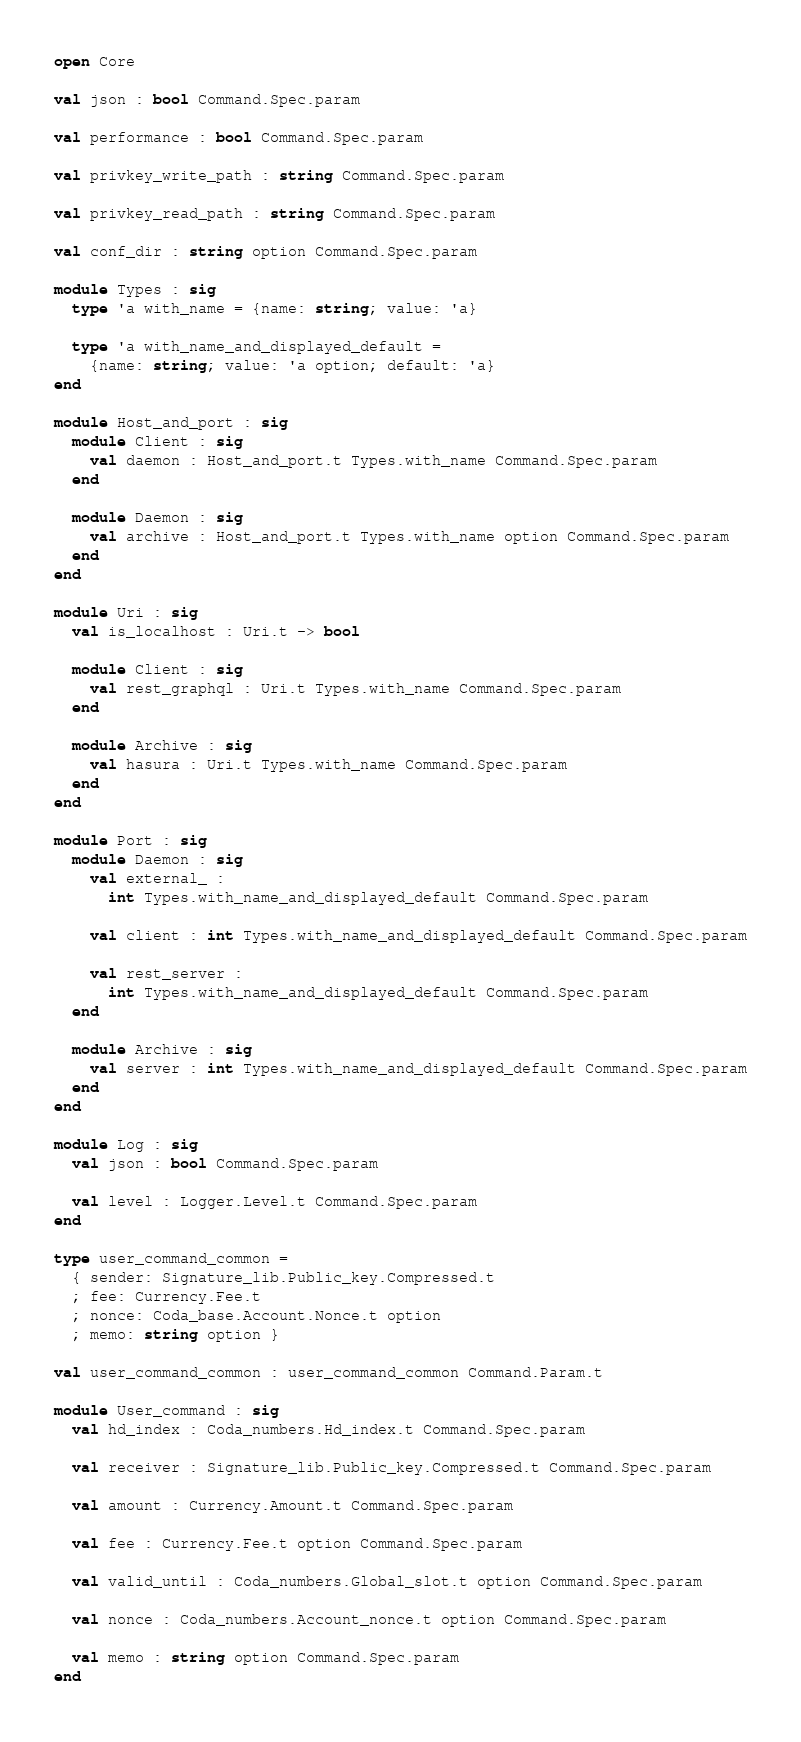Convert code to text. <code><loc_0><loc_0><loc_500><loc_500><_OCaml_>open Core

val json : bool Command.Spec.param

val performance : bool Command.Spec.param

val privkey_write_path : string Command.Spec.param

val privkey_read_path : string Command.Spec.param

val conf_dir : string option Command.Spec.param

module Types : sig
  type 'a with_name = {name: string; value: 'a}

  type 'a with_name_and_displayed_default =
    {name: string; value: 'a option; default: 'a}
end

module Host_and_port : sig
  module Client : sig
    val daemon : Host_and_port.t Types.with_name Command.Spec.param
  end

  module Daemon : sig
    val archive : Host_and_port.t Types.with_name option Command.Spec.param
  end
end

module Uri : sig
  val is_localhost : Uri.t -> bool

  module Client : sig
    val rest_graphql : Uri.t Types.with_name Command.Spec.param
  end

  module Archive : sig
    val hasura : Uri.t Types.with_name Command.Spec.param
  end
end

module Port : sig
  module Daemon : sig
    val external_ :
      int Types.with_name_and_displayed_default Command.Spec.param

    val client : int Types.with_name_and_displayed_default Command.Spec.param

    val rest_server :
      int Types.with_name_and_displayed_default Command.Spec.param
  end

  module Archive : sig
    val server : int Types.with_name_and_displayed_default Command.Spec.param
  end
end

module Log : sig
  val json : bool Command.Spec.param

  val level : Logger.Level.t Command.Spec.param
end

type user_command_common =
  { sender: Signature_lib.Public_key.Compressed.t
  ; fee: Currency.Fee.t
  ; nonce: Coda_base.Account.Nonce.t option
  ; memo: string option }

val user_command_common : user_command_common Command.Param.t

module User_command : sig
  val hd_index : Coda_numbers.Hd_index.t Command.Spec.param

  val receiver : Signature_lib.Public_key.Compressed.t Command.Spec.param

  val amount : Currency.Amount.t Command.Spec.param

  val fee : Currency.Fee.t option Command.Spec.param

  val valid_until : Coda_numbers.Global_slot.t option Command.Spec.param

  val nonce : Coda_numbers.Account_nonce.t option Command.Spec.param

  val memo : string option Command.Spec.param
end
</code> 